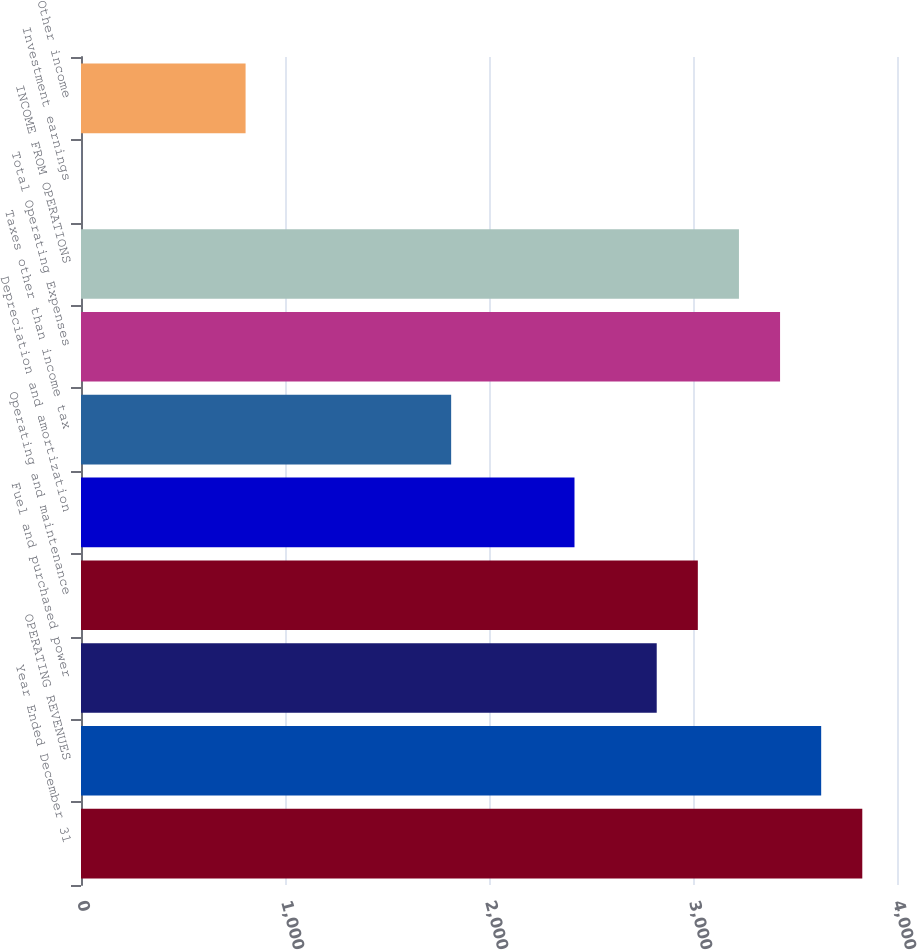Convert chart to OTSL. <chart><loc_0><loc_0><loc_500><loc_500><bar_chart><fcel>Year Ended December 31<fcel>OPERATING REVENUES<fcel>Fuel and purchased power<fcel>Operating and maintenance<fcel>Depreciation and amortization<fcel>Taxes other than income tax<fcel>Total Operating Expenses<fcel>INCOME FROM OPERATIONS<fcel>Investment earnings<fcel>Other income<nl><fcel>3829.86<fcel>3628.32<fcel>2822.16<fcel>3023.7<fcel>2419.08<fcel>1814.46<fcel>3426.78<fcel>3225.24<fcel>0.6<fcel>806.76<nl></chart> 